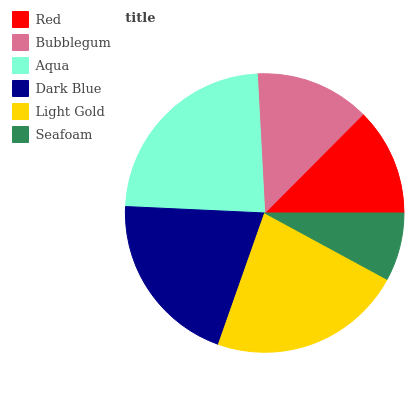Is Seafoam the minimum?
Answer yes or no. Yes. Is Aqua the maximum?
Answer yes or no. Yes. Is Bubblegum the minimum?
Answer yes or no. No. Is Bubblegum the maximum?
Answer yes or no. No. Is Bubblegum greater than Red?
Answer yes or no. Yes. Is Red less than Bubblegum?
Answer yes or no. Yes. Is Red greater than Bubblegum?
Answer yes or no. No. Is Bubblegum less than Red?
Answer yes or no. No. Is Dark Blue the high median?
Answer yes or no. Yes. Is Bubblegum the low median?
Answer yes or no. Yes. Is Seafoam the high median?
Answer yes or no. No. Is Seafoam the low median?
Answer yes or no. No. 